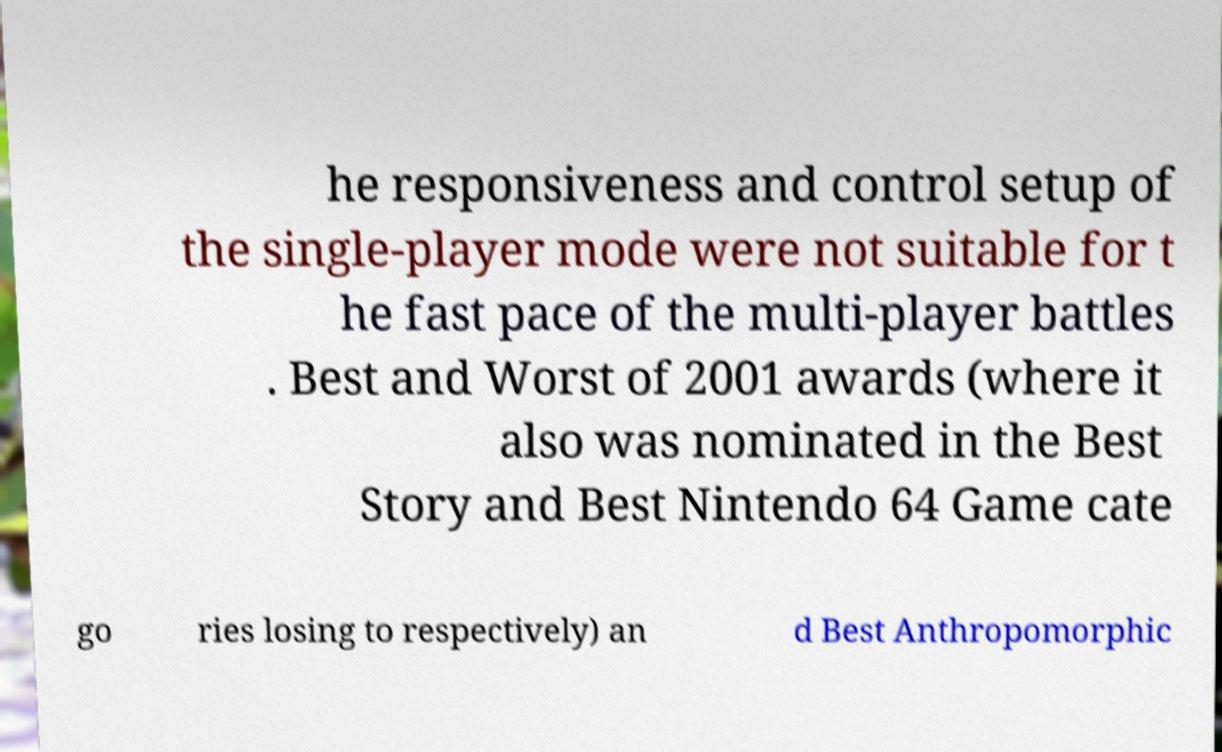I need the written content from this picture converted into text. Can you do that? he responsiveness and control setup of the single-player mode were not suitable for t he fast pace of the multi-player battles . Best and Worst of 2001 awards (where it also was nominated in the Best Story and Best Nintendo 64 Game cate go ries losing to respectively) an d Best Anthropomorphic 